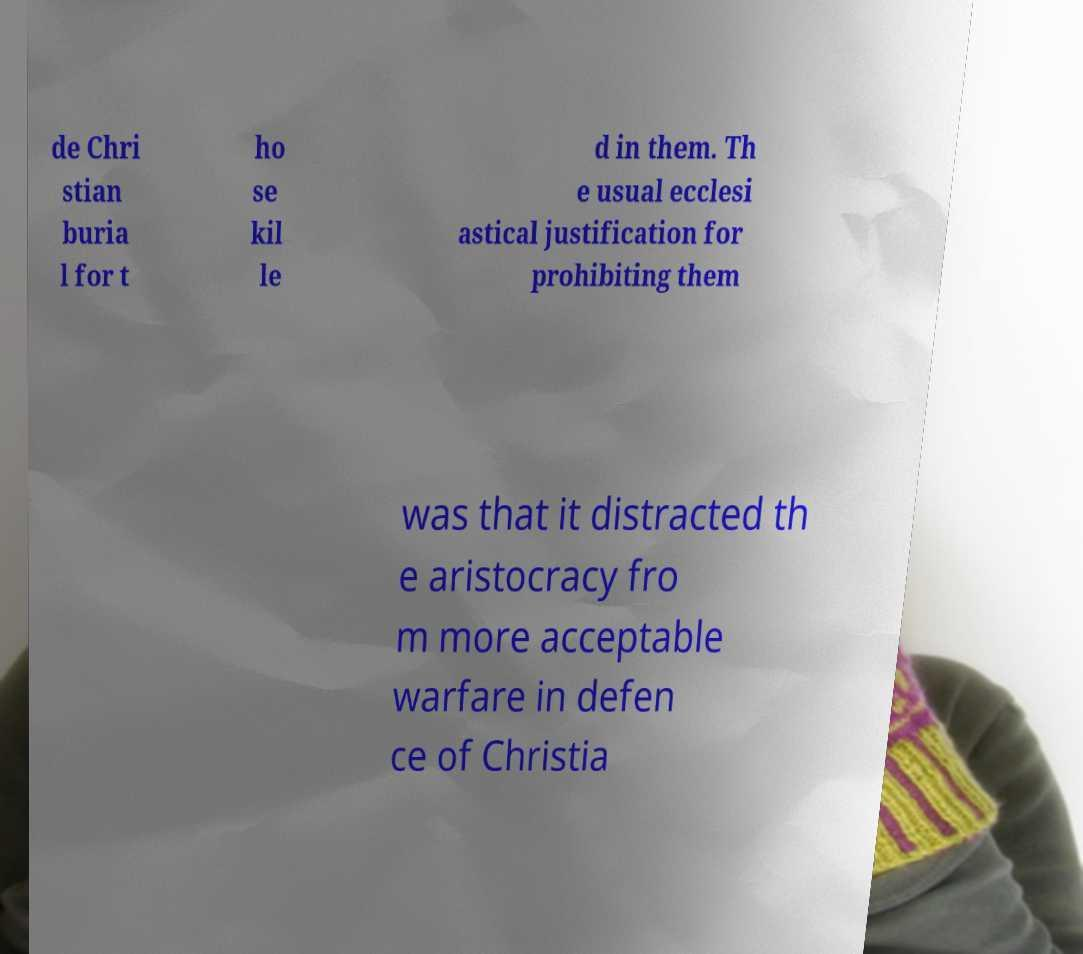Can you accurately transcribe the text from the provided image for me? de Chri stian buria l for t ho se kil le d in them. Th e usual ecclesi astical justification for prohibiting them was that it distracted th e aristocracy fro m more acceptable warfare in defen ce of Christia 